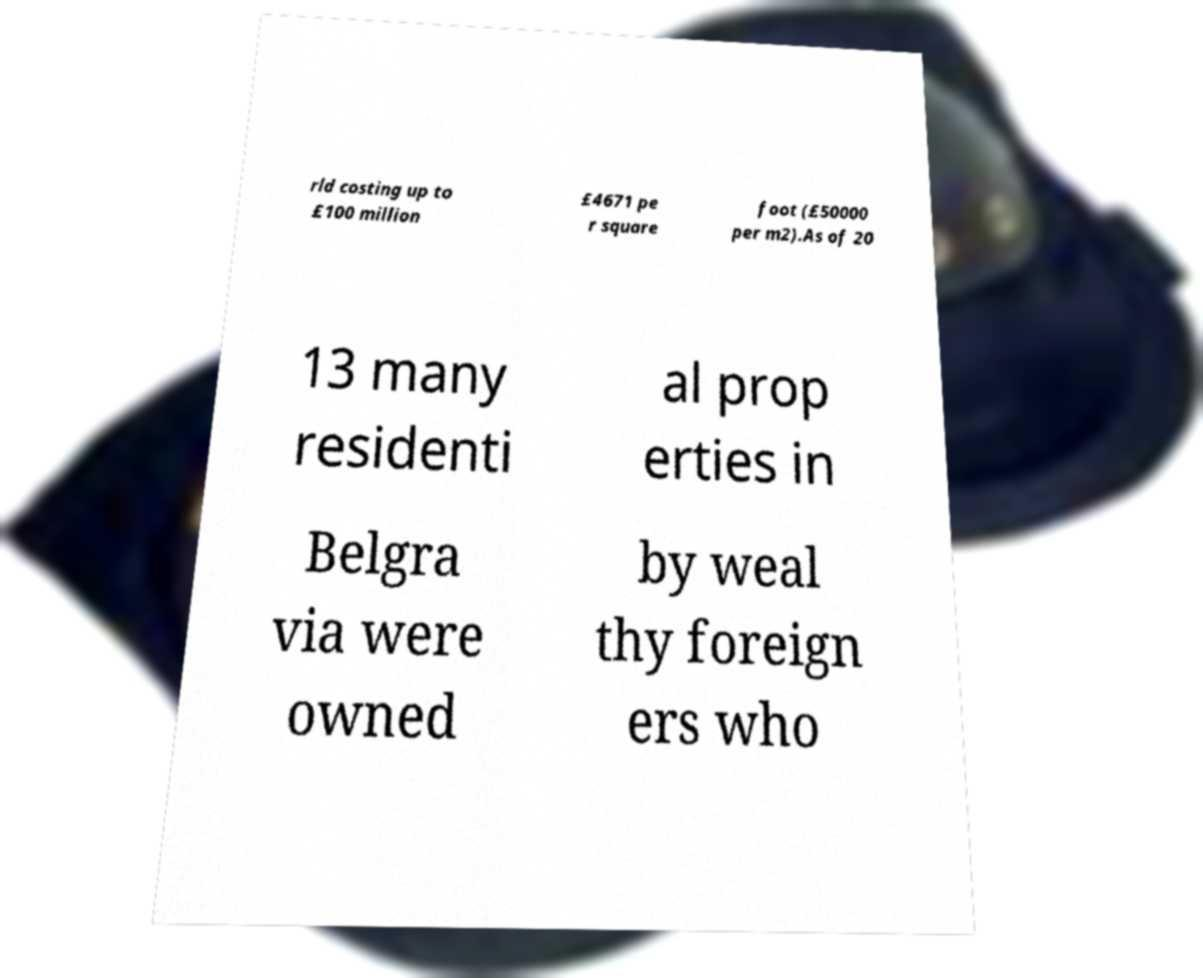Could you extract and type out the text from this image? rld costing up to £100 million £4671 pe r square foot (£50000 per m2).As of 20 13 many residenti al prop erties in Belgra via were owned by weal thy foreign ers who 